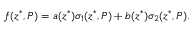<formula> <loc_0><loc_0><loc_500><loc_500>f ( z ^ { \ast } , P ) = a ( z ^ { \ast } ) \sigma _ { 1 } ( z ^ { \ast } , P ) + b ( z ^ { \ast } ) \sigma _ { 2 } ( z ^ { \ast } , P ) .</formula> 